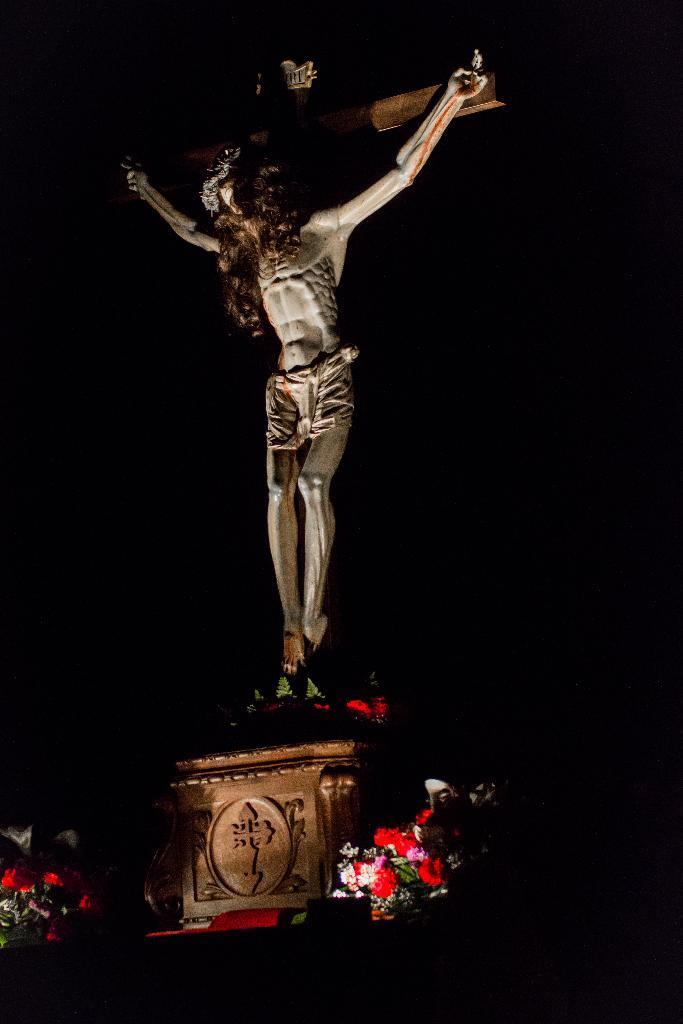What is the main subject in the image? There is a statue in the image. Where is the statue located? The statue is on a platform. What else can be seen on the platform? There are flowers on the platform. How would you describe the background of the image? The background of the image is dark. How does the statue contribute to the plot of the image? The image does not have a plot, as it is a still image of a statue on a platform with flowers. 